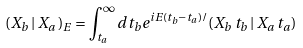<formula> <loc_0><loc_0><loc_500><loc_500>( X _ { b } \, | \, X _ { a } \, ) _ { E } = \int _ { t _ { a } } ^ { \infty } d t _ { b } e ^ { i E ( t _ { b } - t _ { a } ) / } ( X _ { b } \, t _ { b } \, | \, X _ { a } \, t _ { a } )</formula> 